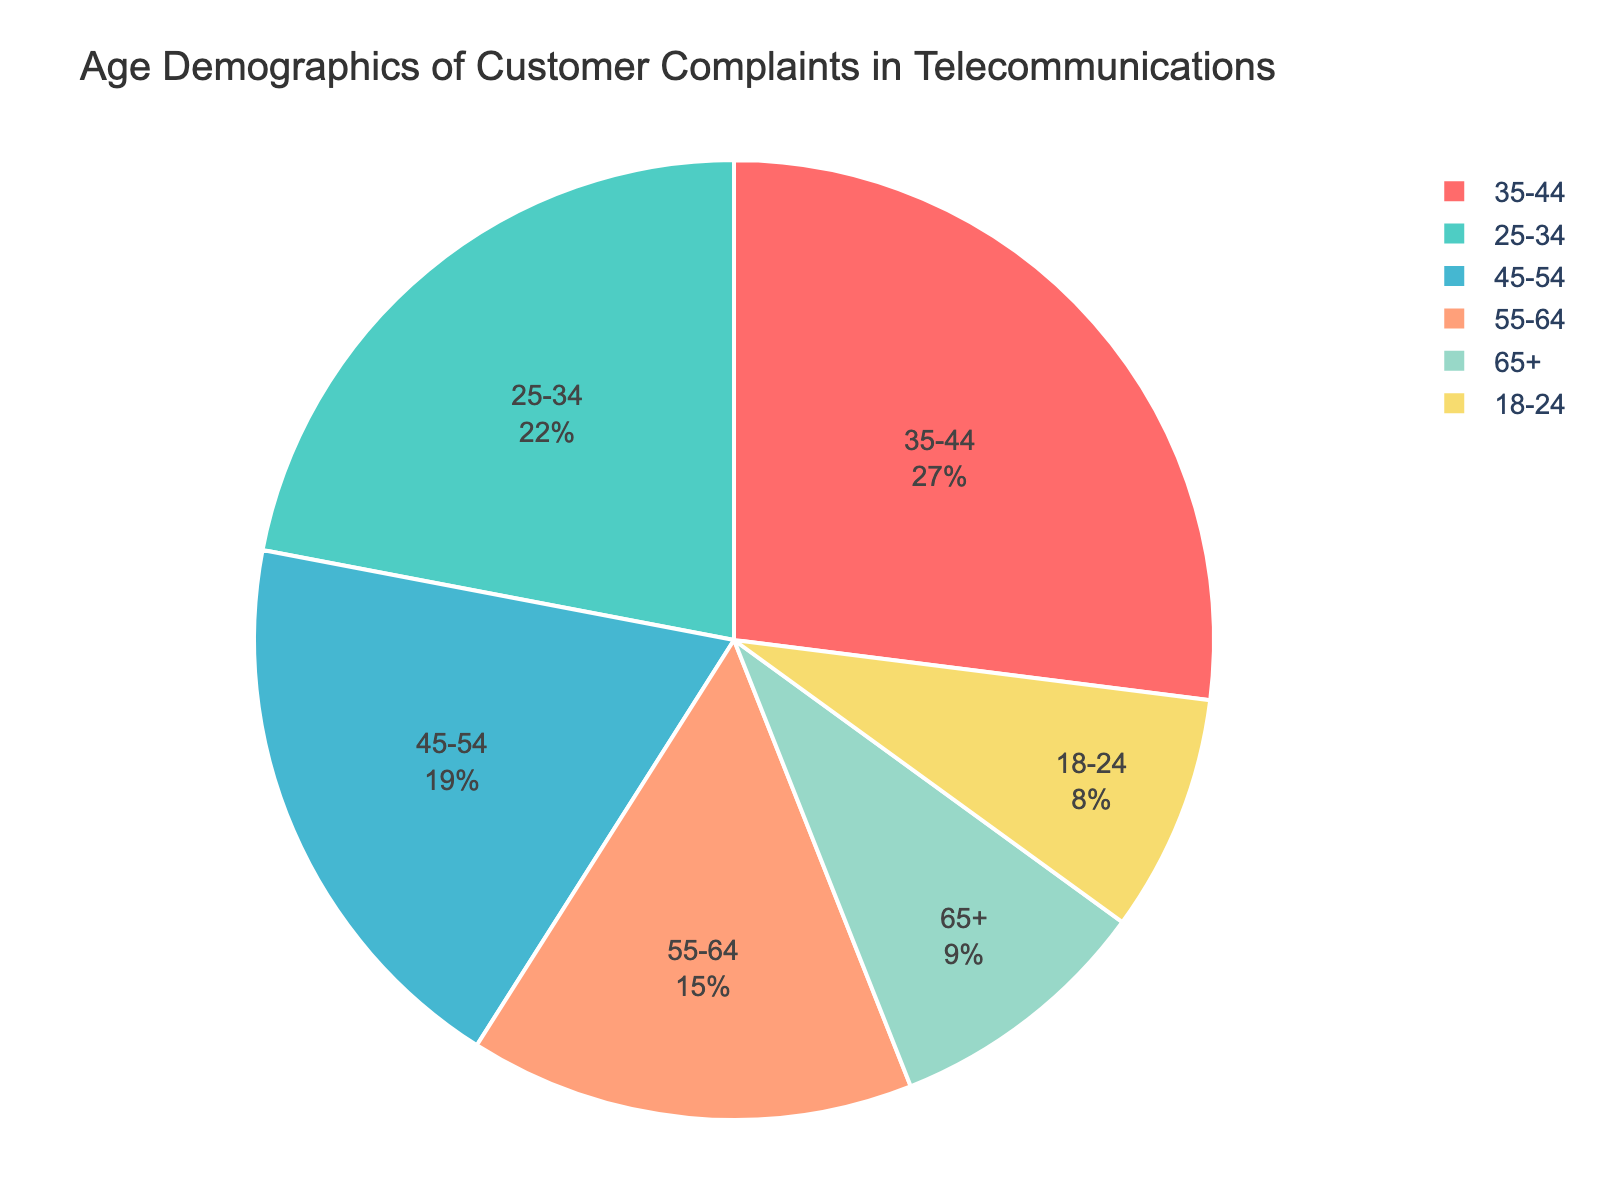What percentage of complaints were submitted by the 35-44 age group? First, identify the segment of the pie chart labeled '35-44'. The percentage associated with this segment is 27%.
Answer: 27% Which age group submitted the least number of complaints? Look for the smallest segment of the pie chart, which represents the age group with the lowest percentage. The slice labeled '18-24' is the smallest at 8%.
Answer: 18-24 How does the percentage of complaints from the 25-34 age group compare to the 55-64 age group? Find the segments labeled '25-34' and '55-64'. The 25-34 segment is 22%, and the 55-64 segment is 15%. Since 22% is greater than 15%, the 25-34 age group submitted a higher percentage of complaints.
Answer: 25-34 > 55-64 What is the combined percentage of complaints submitted by the age groups 18-24, 25-34, and 35-44? Sum the percentages of the slices labeled '18-24', '25-34', and '35-44'. That is 8% + 22% + 27%, which equals 57%.
Answer: 57% Which age group has a larger percentage of complaints, 45-54 or 65+? Locate the segments labeled '45-54' and '65+'. The '45-54' segment shows 19%, while the '65+' segment shows 9%. Since 19% is greater than 9%, the 45-54 age group has a larger percentage of complaints.
Answer: 45-54 What is the range of the percentage values across all age groups? The range is calculated as the difference between the highest and lowest values. The highest percentage is 27% (35-44) and the lowest is 8% (18-24). So, the range is 27% - 8% = 19%.
Answer: 19% Which age group is represented by the segment colored red in the pie chart? Identify the color red in the pie chart. According to the custom color palette used in the plot, the red segment represents the 18-24 age group.
Answer: 18-24 What two age groups collectively contribute to 36% of complaints? Look for two segments whose combined percentage equals 36%. The segments for '55-64' (15%) and '45-54' (19%) add up to 34%. Another combination is '25-34' (22%) and '65+' (9%), which add up to 31%. Only segments for '18-24' (8%) and '45-54' (19%) add up to 27%.
Answer: 18-24 & 45-54 What is the median percentage of complaints across all age groups? To find the median, list the percentages in ascending order: 8%, 9%, 15%, 19%, 22%, 27%. Since there is an even number of values, the median is the average of the 3rd and 4th values: (15% + 19%) / 2 = 17%.
Answer: 17% 